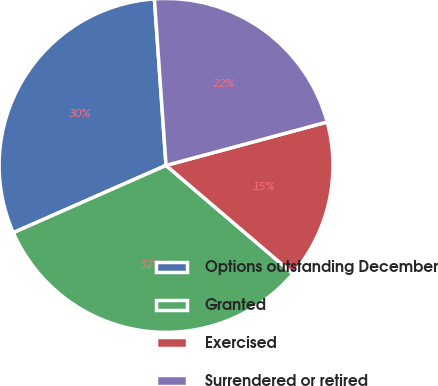<chart> <loc_0><loc_0><loc_500><loc_500><pie_chart><fcel>Options outstanding December<fcel>Granted<fcel>Exercised<fcel>Surrendered or retired<nl><fcel>30.49%<fcel>32.15%<fcel>15.43%<fcel>21.92%<nl></chart> 